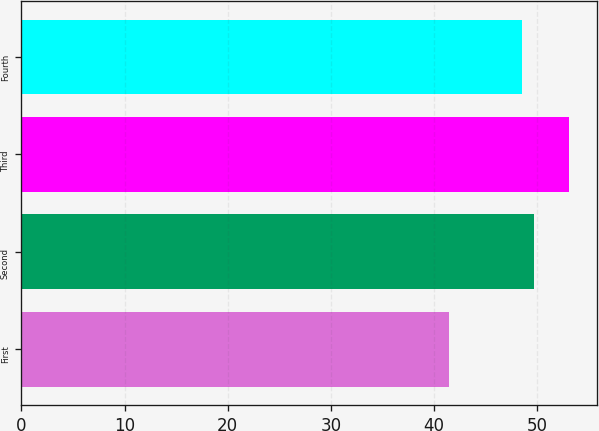<chart> <loc_0><loc_0><loc_500><loc_500><bar_chart><fcel>First<fcel>Second<fcel>Third<fcel>Fourth<nl><fcel>41.48<fcel>49.71<fcel>53.13<fcel>48.55<nl></chart> 